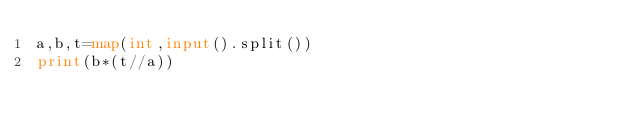<code> <loc_0><loc_0><loc_500><loc_500><_Python_>a,b,t=map(int,input().split())
print(b*(t//a))</code> 